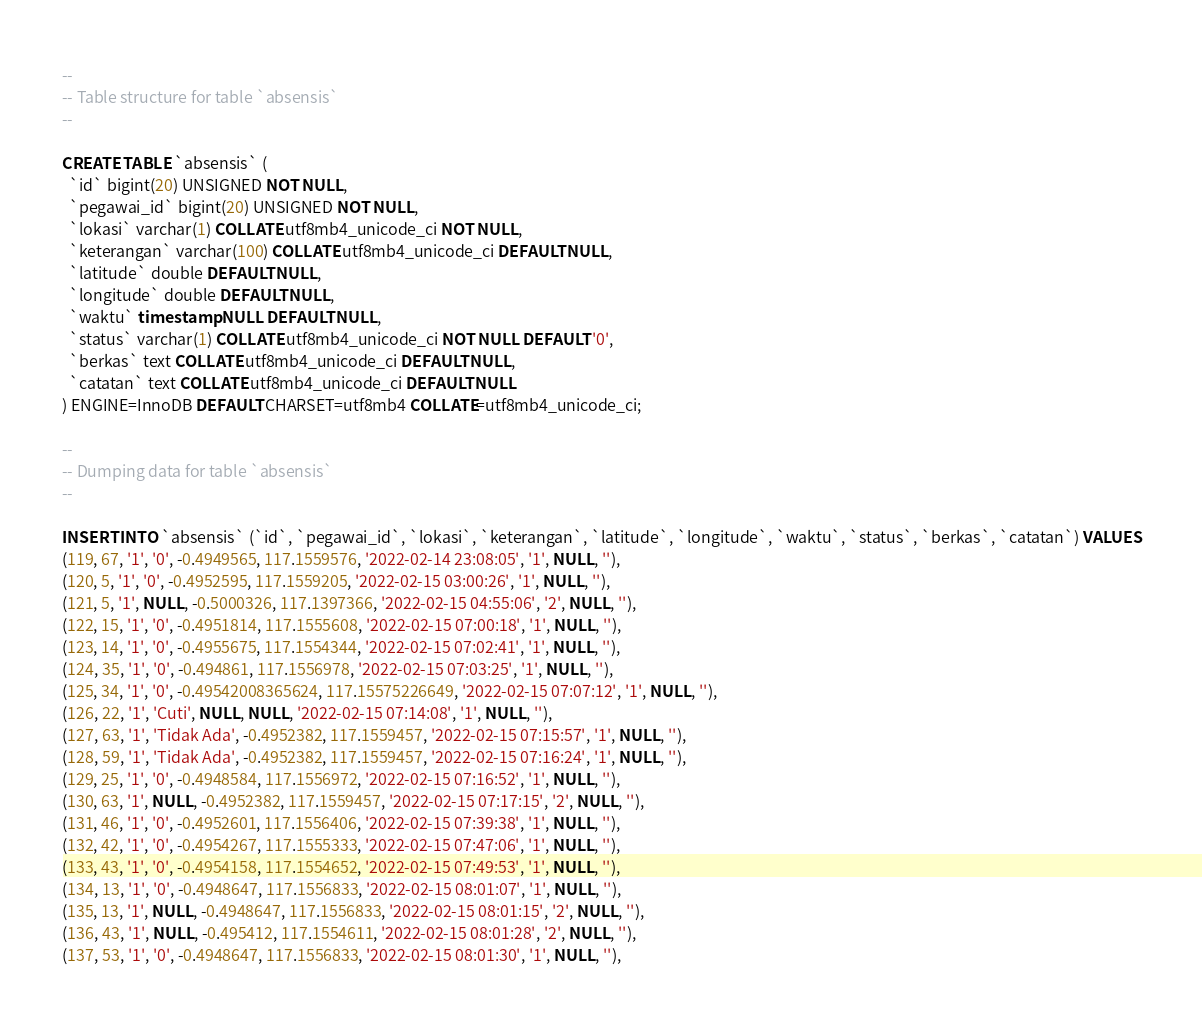Convert code to text. <code><loc_0><loc_0><loc_500><loc_500><_SQL_>--
-- Table structure for table `absensis`
--

CREATE TABLE `absensis` (
  `id` bigint(20) UNSIGNED NOT NULL,
  `pegawai_id` bigint(20) UNSIGNED NOT NULL,
  `lokasi` varchar(1) COLLATE utf8mb4_unicode_ci NOT NULL,
  `keterangan` varchar(100) COLLATE utf8mb4_unicode_ci DEFAULT NULL,
  `latitude` double DEFAULT NULL,
  `longitude` double DEFAULT NULL,
  `waktu` timestamp NULL DEFAULT NULL,
  `status` varchar(1) COLLATE utf8mb4_unicode_ci NOT NULL DEFAULT '0',
  `berkas` text COLLATE utf8mb4_unicode_ci DEFAULT NULL,
  `catatan` text COLLATE utf8mb4_unicode_ci DEFAULT NULL
) ENGINE=InnoDB DEFAULT CHARSET=utf8mb4 COLLATE=utf8mb4_unicode_ci;

--
-- Dumping data for table `absensis`
--

INSERT INTO `absensis` (`id`, `pegawai_id`, `lokasi`, `keterangan`, `latitude`, `longitude`, `waktu`, `status`, `berkas`, `catatan`) VALUES
(119, 67, '1', '0', -0.4949565, 117.1559576, '2022-02-14 23:08:05', '1', NULL, ''),
(120, 5, '1', '0', -0.4952595, 117.1559205, '2022-02-15 03:00:26', '1', NULL, ''),
(121, 5, '1', NULL, -0.5000326, 117.1397366, '2022-02-15 04:55:06', '2', NULL, ''),
(122, 15, '1', '0', -0.4951814, 117.1555608, '2022-02-15 07:00:18', '1', NULL, ''),
(123, 14, '1', '0', -0.4955675, 117.1554344, '2022-02-15 07:02:41', '1', NULL, ''),
(124, 35, '1', '0', -0.494861, 117.1556978, '2022-02-15 07:03:25', '1', NULL, ''),
(125, 34, '1', '0', -0.49542008365624, 117.15575226649, '2022-02-15 07:07:12', '1', NULL, ''),
(126, 22, '1', 'Cuti', NULL, NULL, '2022-02-15 07:14:08', '1', NULL, ''),
(127, 63, '1', 'Tidak Ada', -0.4952382, 117.1559457, '2022-02-15 07:15:57', '1', NULL, ''),
(128, 59, '1', 'Tidak Ada', -0.4952382, 117.1559457, '2022-02-15 07:16:24', '1', NULL, ''),
(129, 25, '1', '0', -0.4948584, 117.1556972, '2022-02-15 07:16:52', '1', NULL, ''),
(130, 63, '1', NULL, -0.4952382, 117.1559457, '2022-02-15 07:17:15', '2', NULL, ''),
(131, 46, '1', '0', -0.4952601, 117.1556406, '2022-02-15 07:39:38', '1', NULL, ''),
(132, 42, '1', '0', -0.4954267, 117.1555333, '2022-02-15 07:47:06', '1', NULL, ''),
(133, 43, '1', '0', -0.4954158, 117.1554652, '2022-02-15 07:49:53', '1', NULL, ''),
(134, 13, '1', '0', -0.4948647, 117.1556833, '2022-02-15 08:01:07', '1', NULL, ''),
(135, 13, '1', NULL, -0.4948647, 117.1556833, '2022-02-15 08:01:15', '2', NULL, ''),
(136, 43, '1', NULL, -0.495412, 117.1554611, '2022-02-15 08:01:28', '2', NULL, ''),
(137, 53, '1', '0', -0.4948647, 117.1556833, '2022-02-15 08:01:30', '1', NULL, ''),</code> 